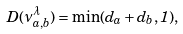<formula> <loc_0><loc_0><loc_500><loc_500>D ( \nu _ { a , b } ^ { \lambda } ) = \min ( d _ { a } + d _ { b } , 1 ) ,</formula> 